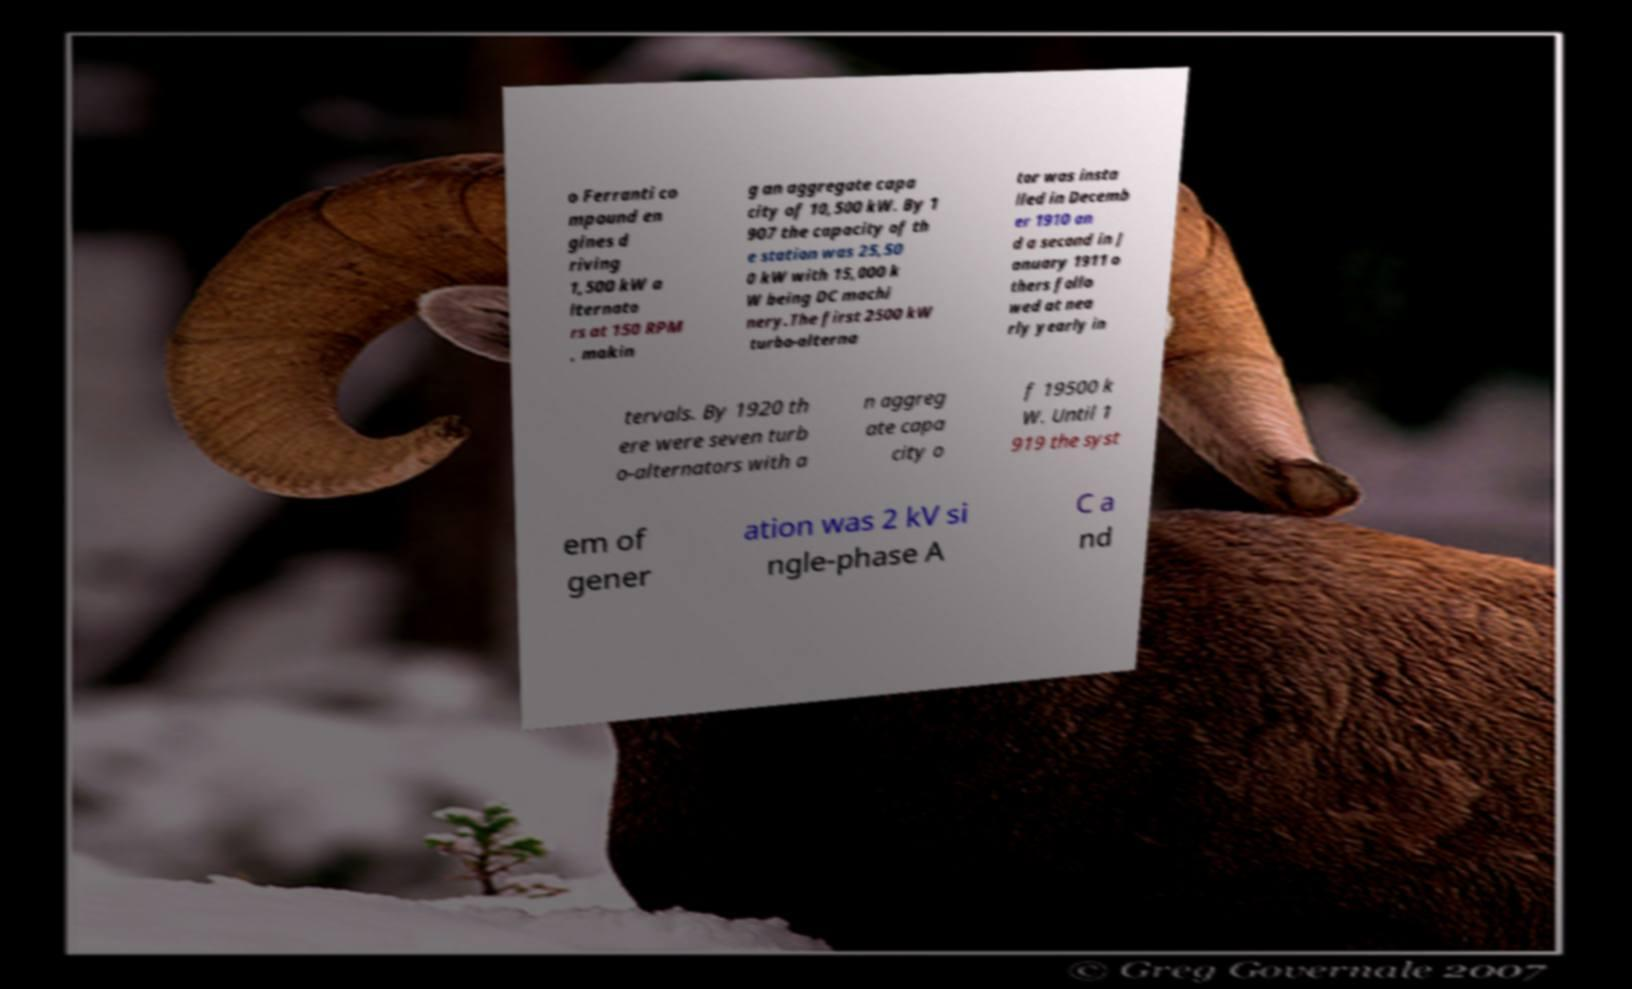What messages or text are displayed in this image? I need them in a readable, typed format. o Ferranti co mpound en gines d riving 1,500 kW a lternato rs at 150 RPM , makin g an aggregate capa city of 10,500 kW. By 1 907 the capacity of th e station was 25,50 0 kW with 15,000 k W being DC machi nery.The first 2500 kW turbo-alterna tor was insta lled in Decemb er 1910 an d a second in J anuary 1911 o thers follo wed at nea rly yearly in tervals. By 1920 th ere were seven turb o-alternators with a n aggreg ate capa city o f 19500 k W. Until 1 919 the syst em of gener ation was 2 kV si ngle-phase A C a nd 